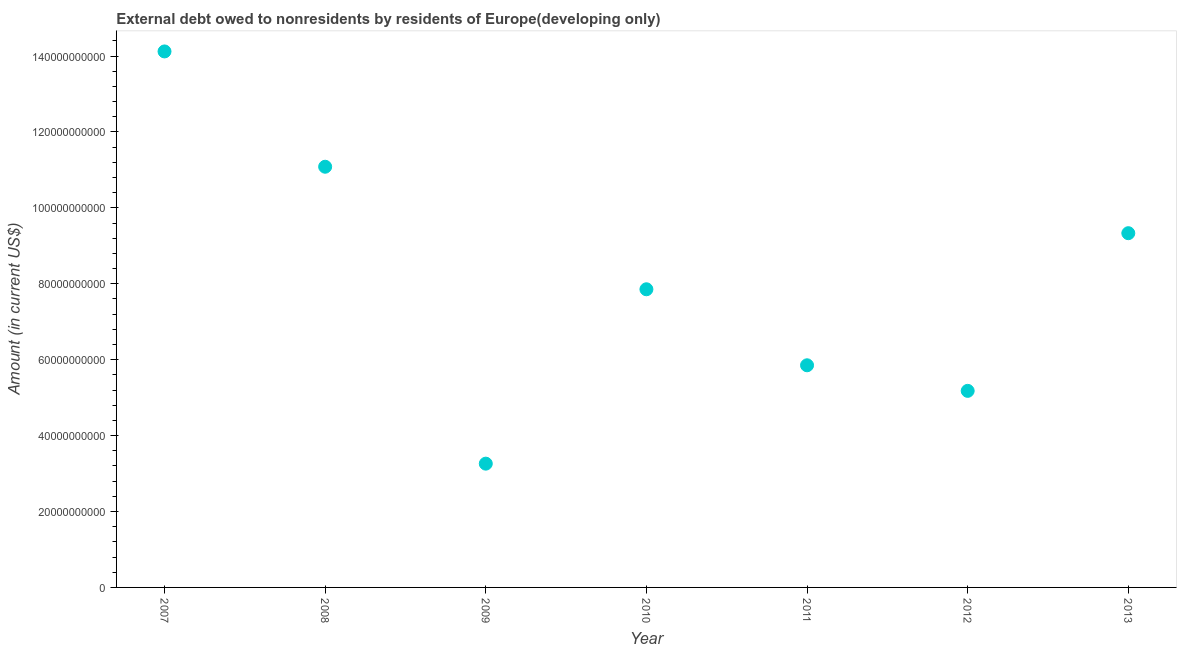What is the debt in 2008?
Provide a short and direct response. 1.11e+11. Across all years, what is the maximum debt?
Your response must be concise. 1.41e+11. Across all years, what is the minimum debt?
Give a very brief answer. 3.26e+1. In which year was the debt minimum?
Keep it short and to the point. 2009. What is the sum of the debt?
Your answer should be very brief. 5.67e+11. What is the difference between the debt in 2008 and 2012?
Ensure brevity in your answer.  5.91e+1. What is the average debt per year?
Offer a very short reply. 8.10e+1. What is the median debt?
Offer a very short reply. 7.86e+1. Do a majority of the years between 2010 and 2011 (inclusive) have debt greater than 124000000000 US$?
Give a very brief answer. No. What is the ratio of the debt in 2012 to that in 2013?
Your response must be concise. 0.55. Is the difference between the debt in 2007 and 2013 greater than the difference between any two years?
Give a very brief answer. No. What is the difference between the highest and the second highest debt?
Your answer should be very brief. 3.04e+1. Is the sum of the debt in 2010 and 2012 greater than the maximum debt across all years?
Give a very brief answer. No. What is the difference between the highest and the lowest debt?
Provide a short and direct response. 1.09e+11. In how many years, is the debt greater than the average debt taken over all years?
Your answer should be very brief. 3. How many dotlines are there?
Give a very brief answer. 1. What is the difference between two consecutive major ticks on the Y-axis?
Provide a succinct answer. 2.00e+1. Are the values on the major ticks of Y-axis written in scientific E-notation?
Give a very brief answer. No. Does the graph contain any zero values?
Keep it short and to the point. No. Does the graph contain grids?
Provide a short and direct response. No. What is the title of the graph?
Provide a succinct answer. External debt owed to nonresidents by residents of Europe(developing only). What is the label or title of the Y-axis?
Make the answer very short. Amount (in current US$). What is the Amount (in current US$) in 2007?
Your answer should be compact. 1.41e+11. What is the Amount (in current US$) in 2008?
Your answer should be compact. 1.11e+11. What is the Amount (in current US$) in 2009?
Your answer should be very brief. 3.26e+1. What is the Amount (in current US$) in 2010?
Your answer should be very brief. 7.86e+1. What is the Amount (in current US$) in 2011?
Provide a succinct answer. 5.85e+1. What is the Amount (in current US$) in 2012?
Give a very brief answer. 5.18e+1. What is the Amount (in current US$) in 2013?
Provide a succinct answer. 9.33e+1. What is the difference between the Amount (in current US$) in 2007 and 2008?
Provide a succinct answer. 3.04e+1. What is the difference between the Amount (in current US$) in 2007 and 2009?
Make the answer very short. 1.09e+11. What is the difference between the Amount (in current US$) in 2007 and 2010?
Your response must be concise. 6.27e+1. What is the difference between the Amount (in current US$) in 2007 and 2011?
Your answer should be very brief. 8.27e+1. What is the difference between the Amount (in current US$) in 2007 and 2012?
Give a very brief answer. 8.94e+1. What is the difference between the Amount (in current US$) in 2007 and 2013?
Keep it short and to the point. 4.79e+1. What is the difference between the Amount (in current US$) in 2008 and 2009?
Offer a very short reply. 7.82e+1. What is the difference between the Amount (in current US$) in 2008 and 2010?
Provide a short and direct response. 3.23e+1. What is the difference between the Amount (in current US$) in 2008 and 2011?
Give a very brief answer. 5.23e+1. What is the difference between the Amount (in current US$) in 2008 and 2012?
Keep it short and to the point. 5.91e+1. What is the difference between the Amount (in current US$) in 2008 and 2013?
Make the answer very short. 1.75e+1. What is the difference between the Amount (in current US$) in 2009 and 2010?
Give a very brief answer. -4.59e+1. What is the difference between the Amount (in current US$) in 2009 and 2011?
Offer a very short reply. -2.59e+1. What is the difference between the Amount (in current US$) in 2009 and 2012?
Your response must be concise. -1.92e+1. What is the difference between the Amount (in current US$) in 2009 and 2013?
Offer a very short reply. -6.07e+1. What is the difference between the Amount (in current US$) in 2010 and 2011?
Give a very brief answer. 2.00e+1. What is the difference between the Amount (in current US$) in 2010 and 2012?
Your response must be concise. 2.68e+1. What is the difference between the Amount (in current US$) in 2010 and 2013?
Your answer should be very brief. -1.48e+1. What is the difference between the Amount (in current US$) in 2011 and 2012?
Provide a short and direct response. 6.74e+09. What is the difference between the Amount (in current US$) in 2011 and 2013?
Offer a very short reply. -3.48e+1. What is the difference between the Amount (in current US$) in 2012 and 2013?
Provide a short and direct response. -4.15e+1. What is the ratio of the Amount (in current US$) in 2007 to that in 2008?
Offer a terse response. 1.27. What is the ratio of the Amount (in current US$) in 2007 to that in 2009?
Your answer should be compact. 4.33. What is the ratio of the Amount (in current US$) in 2007 to that in 2010?
Provide a succinct answer. 1.8. What is the ratio of the Amount (in current US$) in 2007 to that in 2011?
Provide a short and direct response. 2.41. What is the ratio of the Amount (in current US$) in 2007 to that in 2012?
Your answer should be very brief. 2.73. What is the ratio of the Amount (in current US$) in 2007 to that in 2013?
Provide a succinct answer. 1.51. What is the ratio of the Amount (in current US$) in 2008 to that in 2009?
Give a very brief answer. 3.4. What is the ratio of the Amount (in current US$) in 2008 to that in 2010?
Your answer should be very brief. 1.41. What is the ratio of the Amount (in current US$) in 2008 to that in 2011?
Ensure brevity in your answer.  1.89. What is the ratio of the Amount (in current US$) in 2008 to that in 2012?
Make the answer very short. 2.14. What is the ratio of the Amount (in current US$) in 2008 to that in 2013?
Provide a succinct answer. 1.19. What is the ratio of the Amount (in current US$) in 2009 to that in 2010?
Keep it short and to the point. 0.41. What is the ratio of the Amount (in current US$) in 2009 to that in 2011?
Offer a very short reply. 0.56. What is the ratio of the Amount (in current US$) in 2009 to that in 2012?
Offer a very short reply. 0.63. What is the ratio of the Amount (in current US$) in 2009 to that in 2013?
Your answer should be very brief. 0.35. What is the ratio of the Amount (in current US$) in 2010 to that in 2011?
Your answer should be compact. 1.34. What is the ratio of the Amount (in current US$) in 2010 to that in 2012?
Give a very brief answer. 1.52. What is the ratio of the Amount (in current US$) in 2010 to that in 2013?
Provide a succinct answer. 0.84. What is the ratio of the Amount (in current US$) in 2011 to that in 2012?
Provide a short and direct response. 1.13. What is the ratio of the Amount (in current US$) in 2011 to that in 2013?
Provide a short and direct response. 0.63. What is the ratio of the Amount (in current US$) in 2012 to that in 2013?
Your answer should be compact. 0.56. 